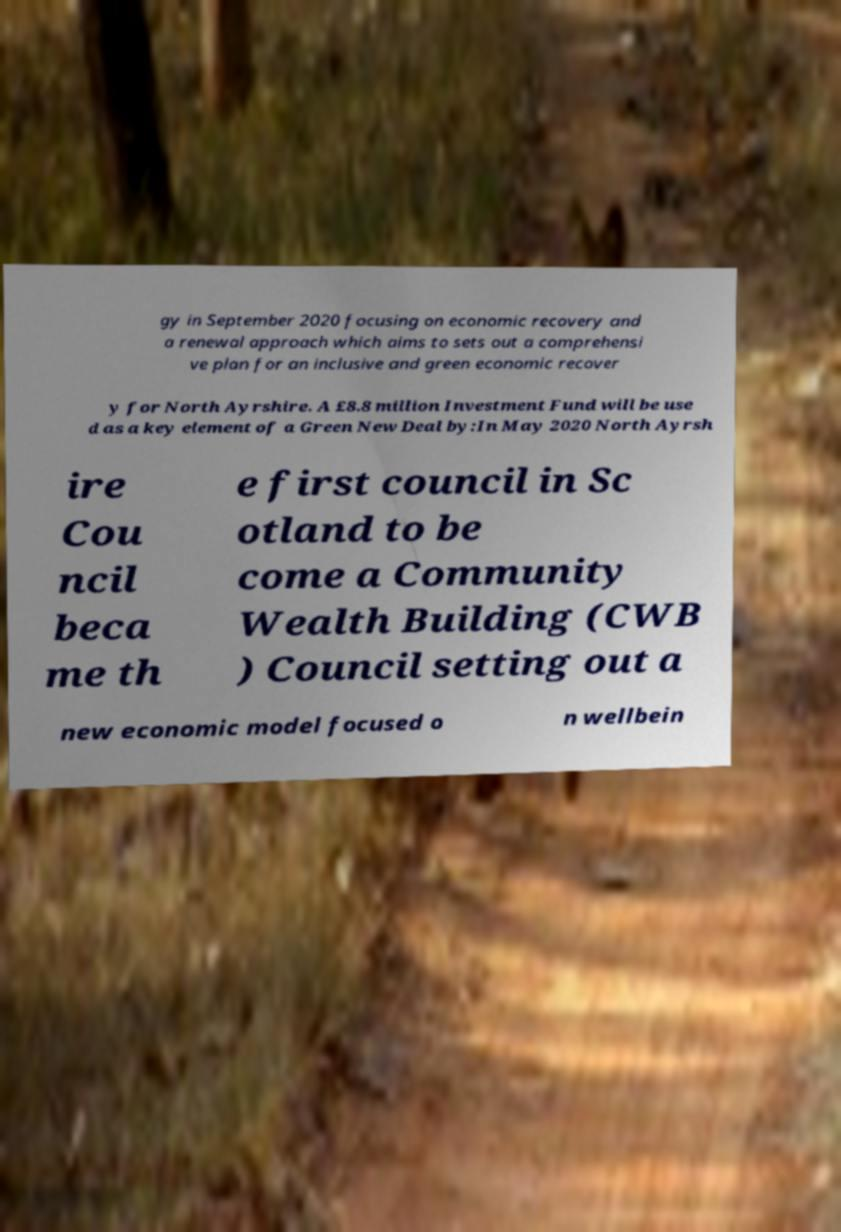For documentation purposes, I need the text within this image transcribed. Could you provide that? gy in September 2020 focusing on economic recovery and a renewal approach which aims to sets out a comprehensi ve plan for an inclusive and green economic recover y for North Ayrshire. A £8.8 million Investment Fund will be use d as a key element of a Green New Deal by:In May 2020 North Ayrsh ire Cou ncil beca me th e first council in Sc otland to be come a Community Wealth Building (CWB ) Council setting out a new economic model focused o n wellbein 